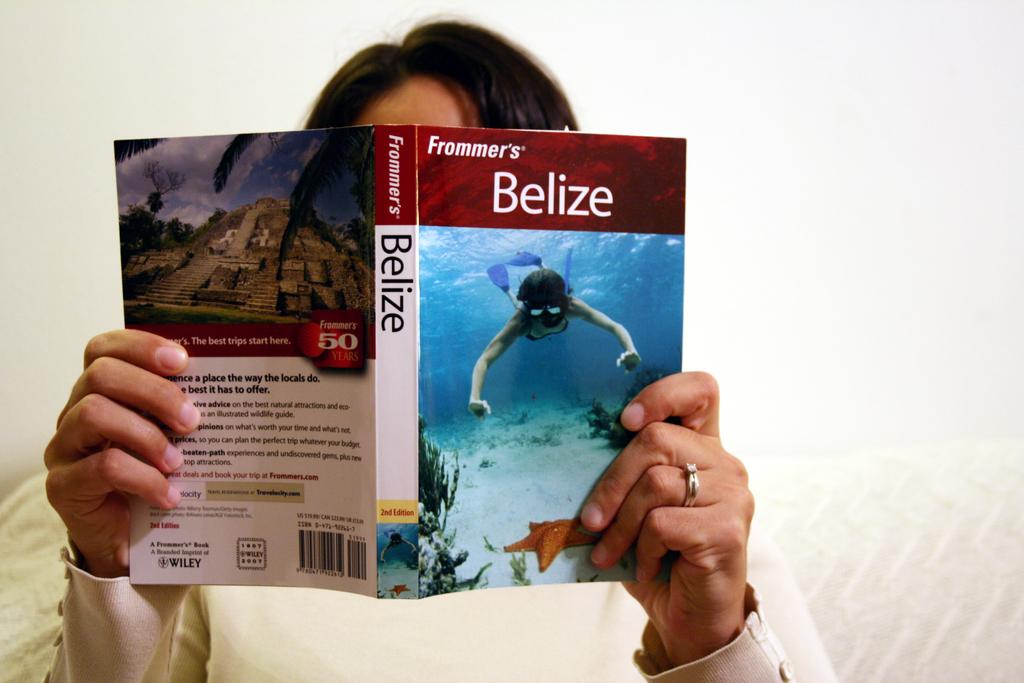<image>
Present a compact description of the photo's key features. A person reading a book about traveling in Belize. 